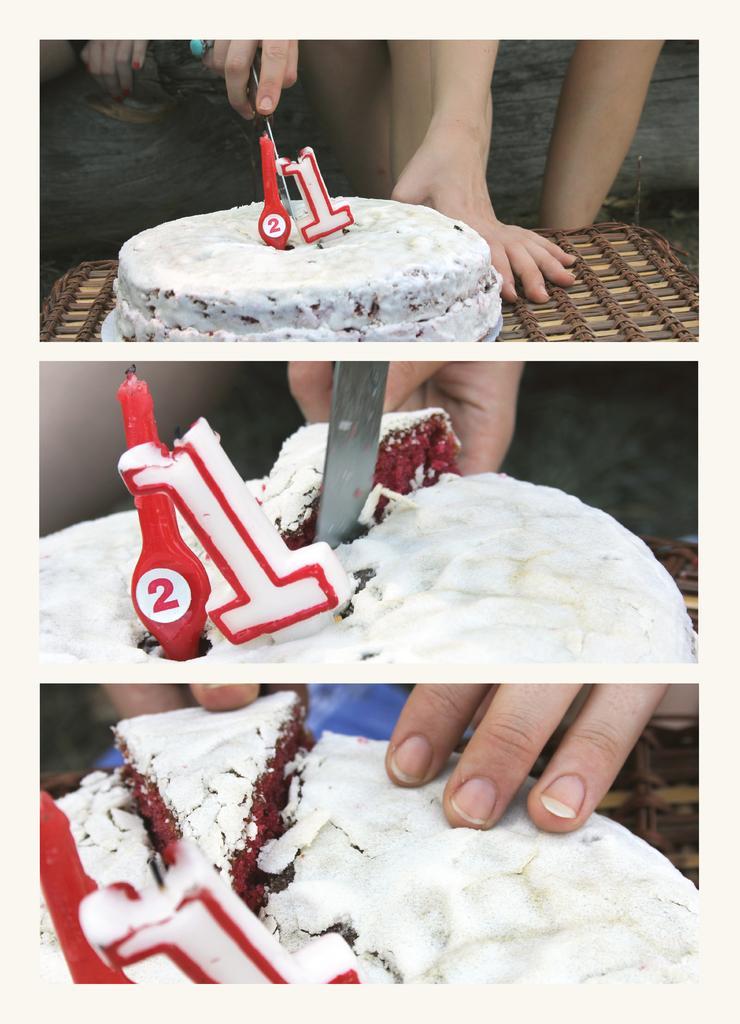Please provide a concise description of this image. This is a collage image in this image there are three images of a cake, in first image there is a cake on a table, in the background there is a person cutting the cake in next two images there are cakes. 